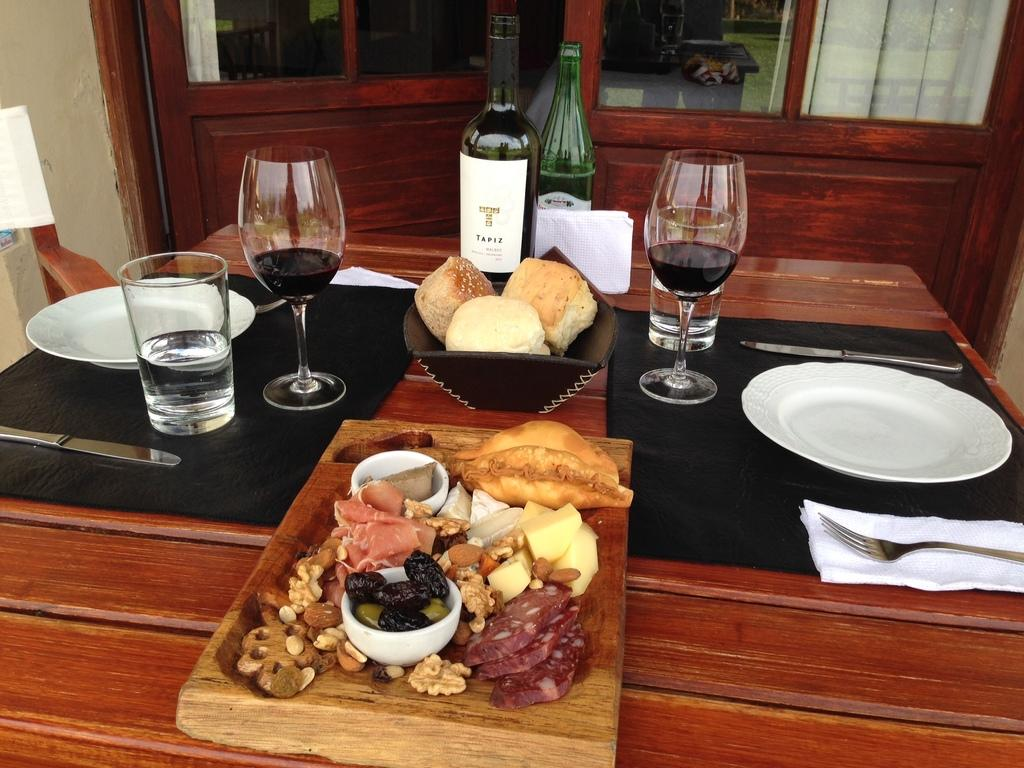What type of furniture is in the image? There is a dining table in the image. What can be found on the dining table? Food items, a glass, spoons, and a wine bottle are present on the dining table. Are there any other objects on the dining table? Yes, there are other objects on the dining table. What is located in front of the dining table? There is a door in front of the dining table. What type of lace is draped over the wine bottle in the image? There is no lace present in the image, and no lace is draped over the wine bottle. Can you tell me what the father is doing in the image? There is no person, let alone a father, present in the image. 